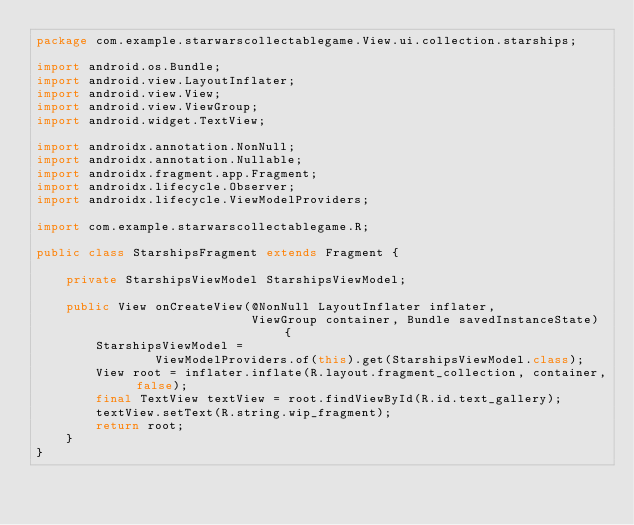<code> <loc_0><loc_0><loc_500><loc_500><_Java_>package com.example.starwarscollectablegame.View.ui.collection.starships;

import android.os.Bundle;
import android.view.LayoutInflater;
import android.view.View;
import android.view.ViewGroup;
import android.widget.TextView;

import androidx.annotation.NonNull;
import androidx.annotation.Nullable;
import androidx.fragment.app.Fragment;
import androidx.lifecycle.Observer;
import androidx.lifecycle.ViewModelProviders;

import com.example.starwarscollectablegame.R;

public class StarshipsFragment extends Fragment {

    private StarshipsViewModel StarshipsViewModel;

    public View onCreateView(@NonNull LayoutInflater inflater,
                             ViewGroup container, Bundle savedInstanceState) {
        StarshipsViewModel =
                ViewModelProviders.of(this).get(StarshipsViewModel.class);
        View root = inflater.inflate(R.layout.fragment_collection, container, false);
        final TextView textView = root.findViewById(R.id.text_gallery);
        textView.setText(R.string.wip_fragment);
        return root;
    }
}</code> 